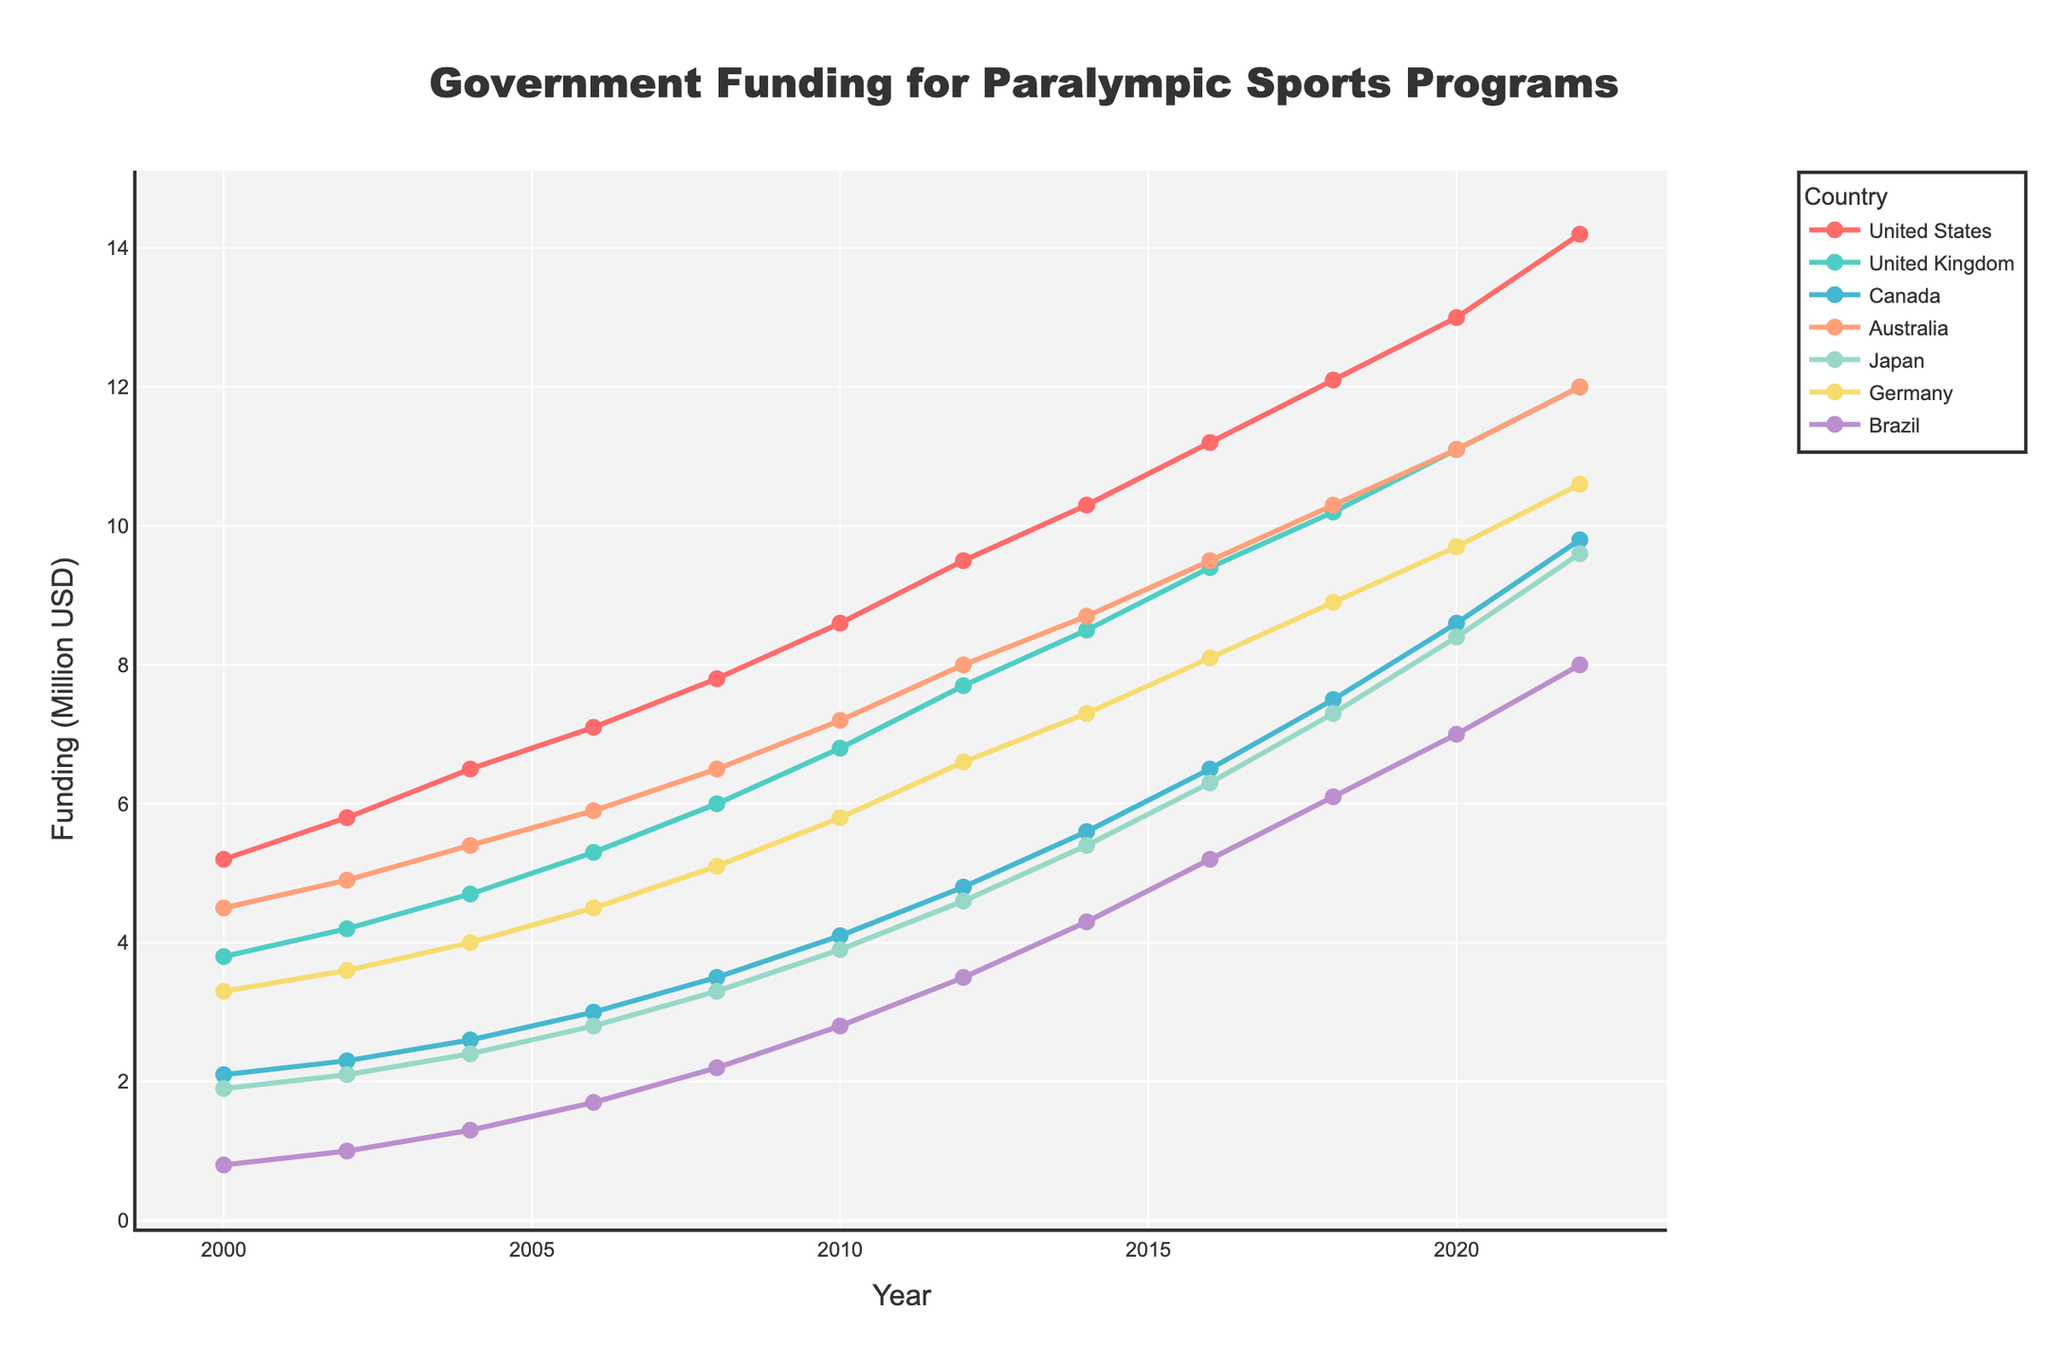what is the total government funding for Paralympic sports programs in Brazil over the years 2000 to 2022? Sum up the values for Brazil over the given years: 0.8+1.0+1.3+1.7+2.2+2.8+3.5+4.3+5.2+6.1+7.0+8.0 = 43.9 million USD
Answer: 43.9 million USD Which country had the highest funding in 2018? According to the 2018 data, the funding levels are: United States: 12.1, United Kingdom: 10.2, Canada: 7.5, Australia: 10.3, Japan: 7.3, Germany: 8.9, Brazil: 6.1. The highest funding was in the United States.
Answer: United States How did Canada's funding in 2012 compare to 2020? Canada's funding in 2012 was 4.8 and in 2020 it was 8.6. The difference is 8.6 - 4.8 = 3.8 million USD.
Answer: 3.8 million USD By how much did Japan's funding increase between 2006 and 2022? Funding for Japan in 2006 was 2.8 and in 2022 it was 9.6. Increase: 9.6 - 2.8 = 6.8 million USD
Answer: 6.8 million USD Which country had the lowest funding in 2004? According to the 2004 data: United States: 6.5, United Kingdom: 4.7, Canada: 2.6, Australia: 5.4, Japan: 2.4, Germany: 4.0, Brazil: 1.3. The lowest funding was in Brazil.
Answer: Brazil What can be said about the funding trend of Germany from 2000 to 2022? Germany's funding increases steadily over the years: 3.3 in 2000, 3.6 in 2002, ..., up to 10.6 in 2022 with no drop in values. This indicates a consistent upward trend.
Answer: Steady increase Calculate the average funding for Australia over the entire period? Sum up the values for Australia: 4.5+4.9+5.4+5.9+6.5+7.2+8.0+8.7+9.5+10.3+11.1+12.0 = 94.0. There're 12 years, so the average is 94.0 / 12 ≈ 7.83 million USD.
Answer: 7.83 million USD Which two countries had the closest funding in 2020? Compare 2020 data: United States: 13.0, United Kingdom: 11.1, Canada: 8.6, Australia: 11.1, Japan: 8.4, Germany: 9.7, Brazil: 7.0. The United Kingdom and Australia both had the same value.
Answer: United Kingdom and Australia How did the funding for the United States change from 2000 to 2010? Funding in 2000 was 5.2 and in 2010 it was 8.6. Change: 8.6 - 5.2 = 3.4 million USD increase
Answer: Increased by 3.4 million USD 